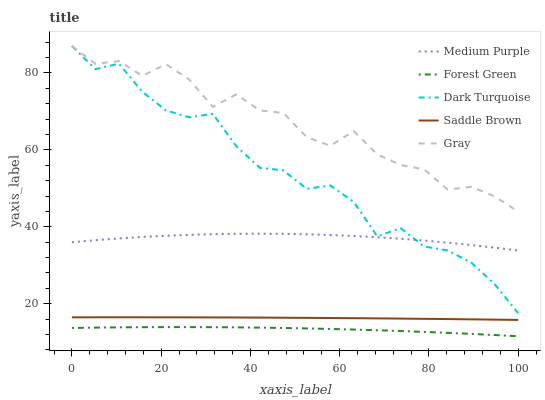Does Forest Green have the minimum area under the curve?
Answer yes or no. Yes. Does Gray have the maximum area under the curve?
Answer yes or no. Yes. Does Dark Turquoise have the minimum area under the curve?
Answer yes or no. No. Does Dark Turquoise have the maximum area under the curve?
Answer yes or no. No. Is Saddle Brown the smoothest?
Answer yes or no. Yes. Is Gray the roughest?
Answer yes or no. Yes. Is Dark Turquoise the smoothest?
Answer yes or no. No. Is Dark Turquoise the roughest?
Answer yes or no. No. Does Forest Green have the lowest value?
Answer yes or no. Yes. Does Dark Turquoise have the lowest value?
Answer yes or no. No. Does Gray have the highest value?
Answer yes or no. Yes. Does Forest Green have the highest value?
Answer yes or no. No. Is Saddle Brown less than Medium Purple?
Answer yes or no. Yes. Is Dark Turquoise greater than Saddle Brown?
Answer yes or no. Yes. Does Gray intersect Dark Turquoise?
Answer yes or no. Yes. Is Gray less than Dark Turquoise?
Answer yes or no. No. Is Gray greater than Dark Turquoise?
Answer yes or no. No. Does Saddle Brown intersect Medium Purple?
Answer yes or no. No. 